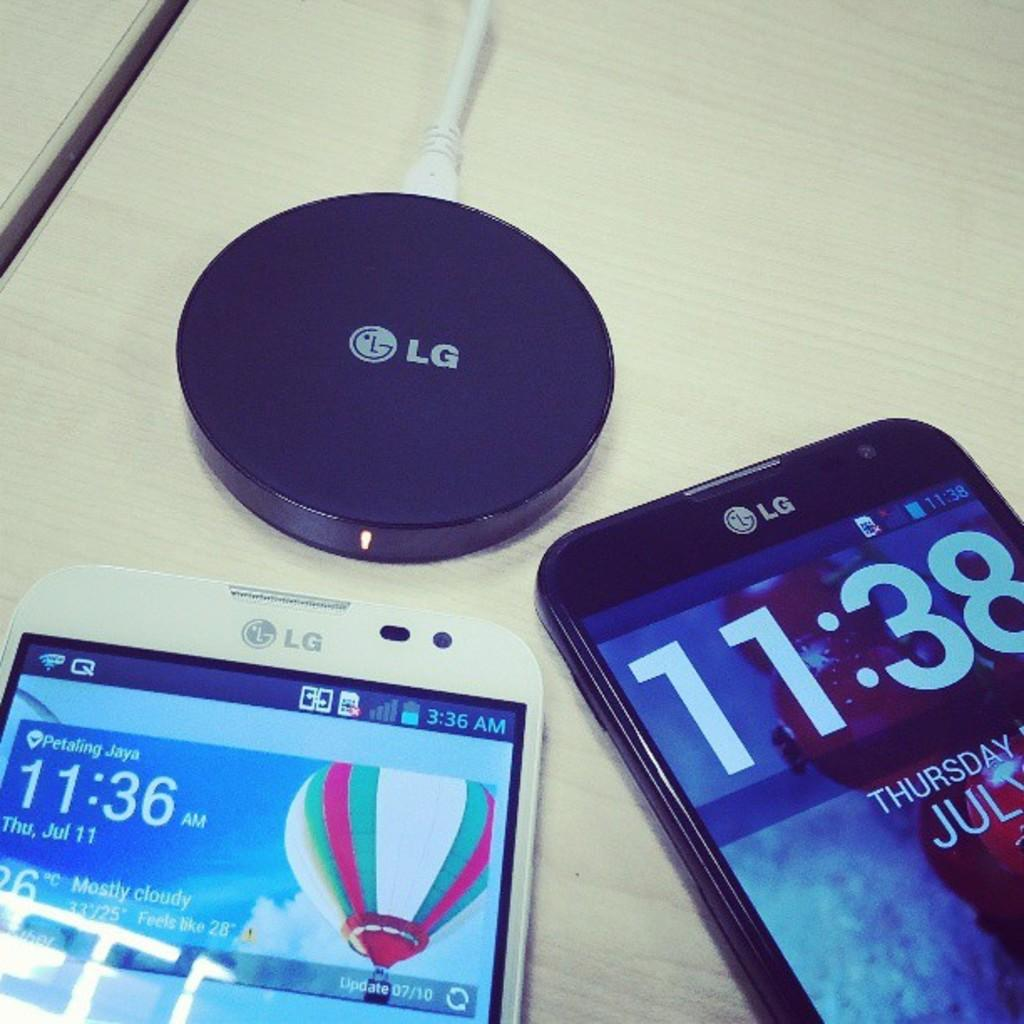<image>
Share a concise interpretation of the image provided. An LG phone which displays the time as being 11.38. 